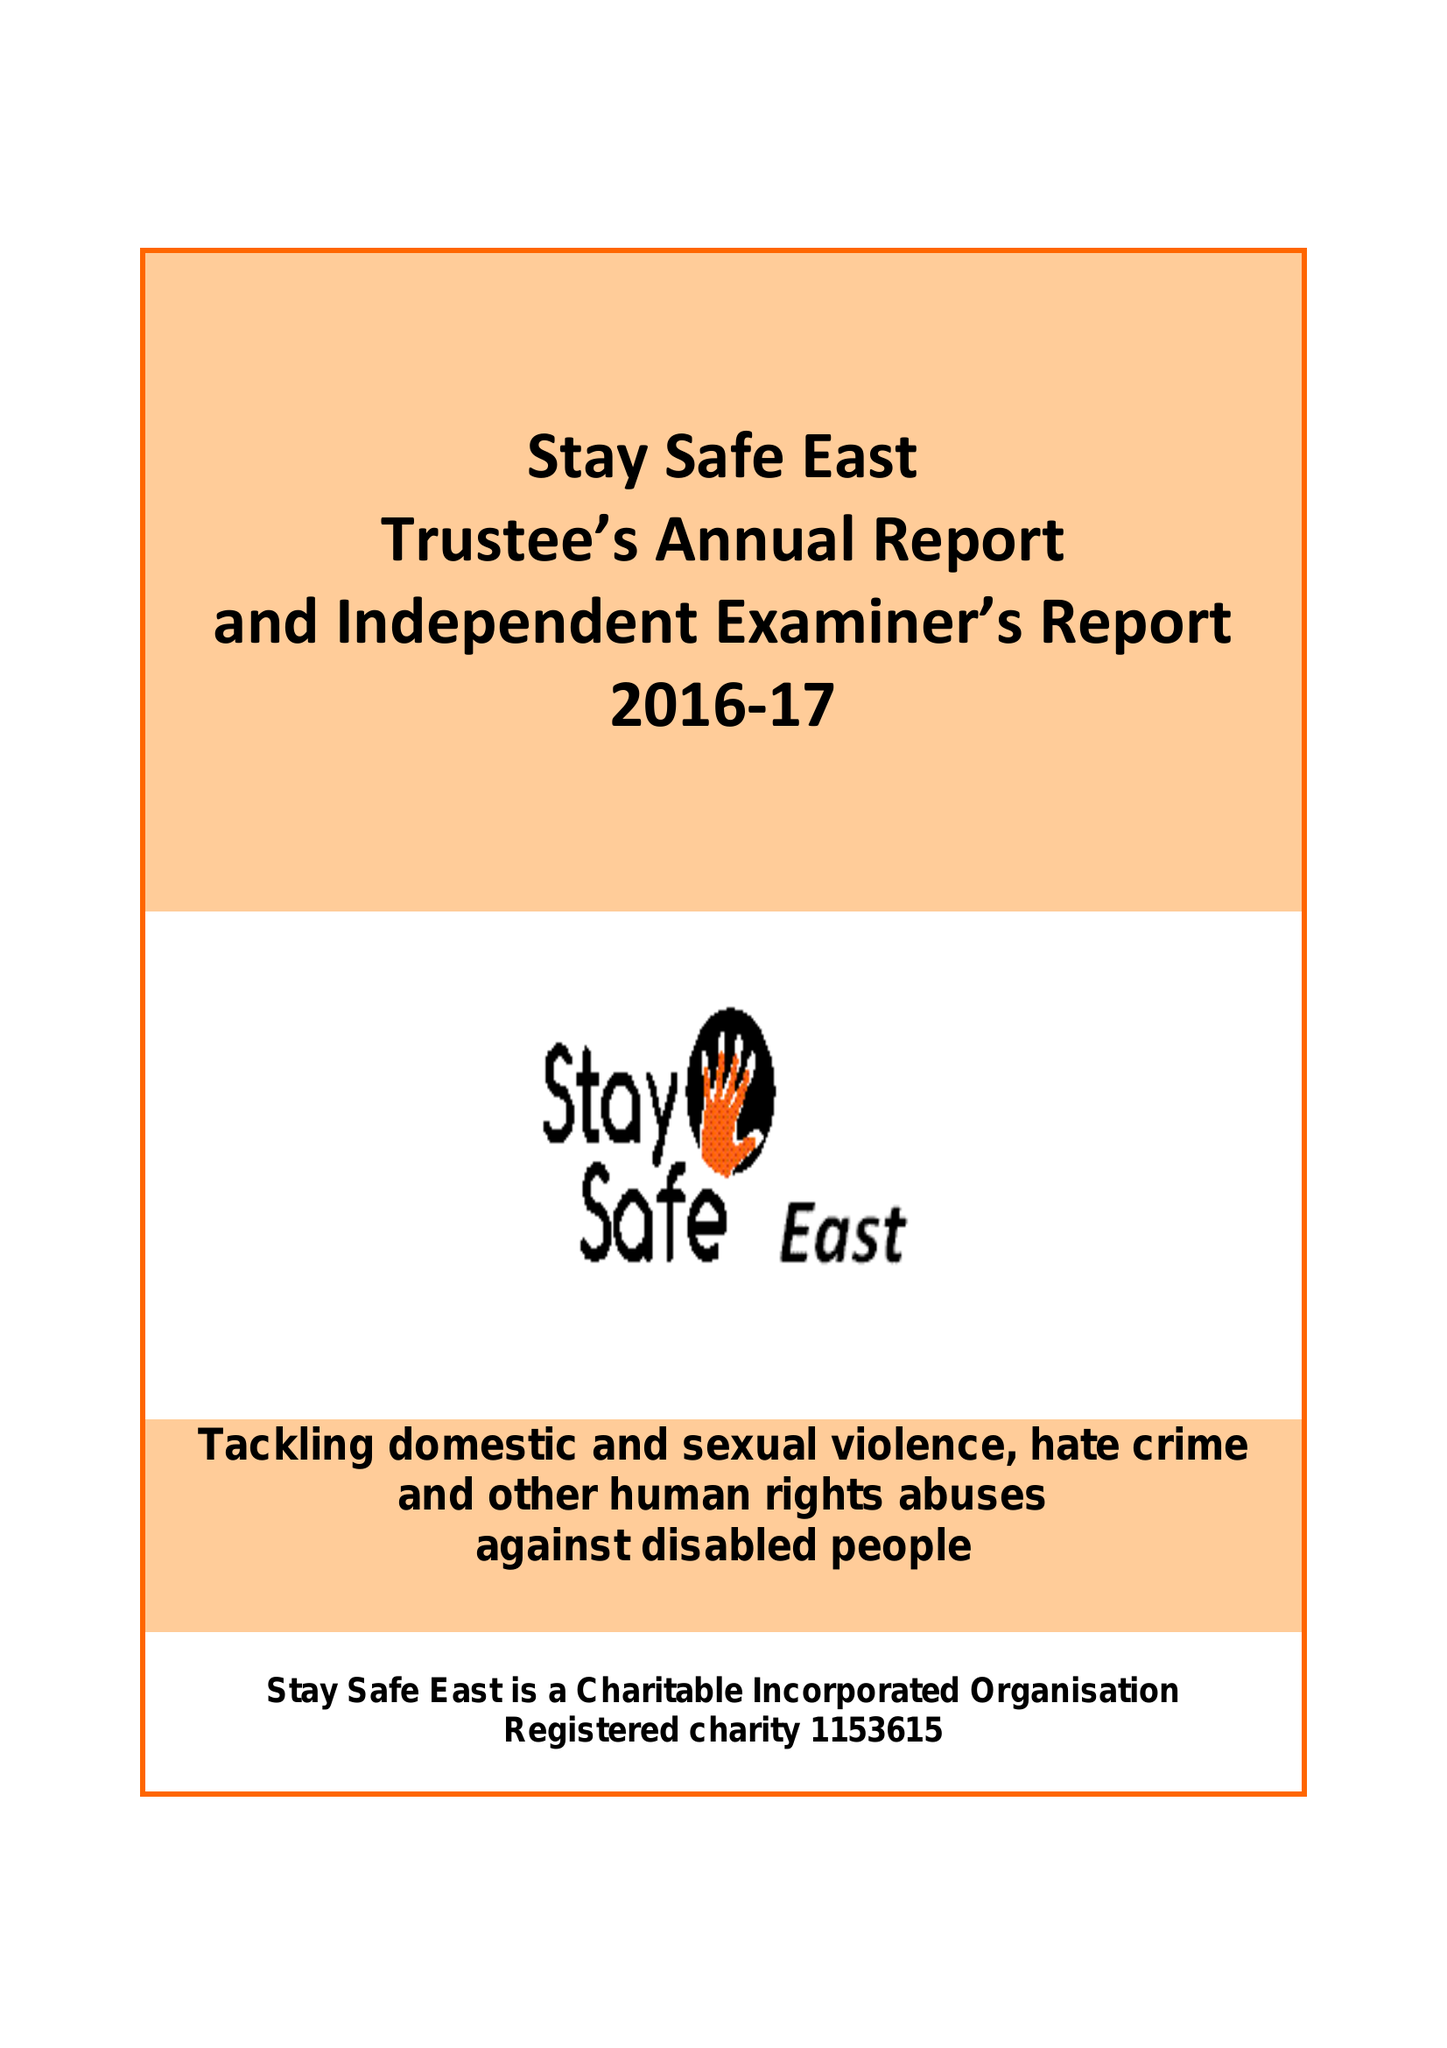What is the value for the address__street_line?
Answer the question using a single word or phrase. 90 CROWNFIELD ROAD 